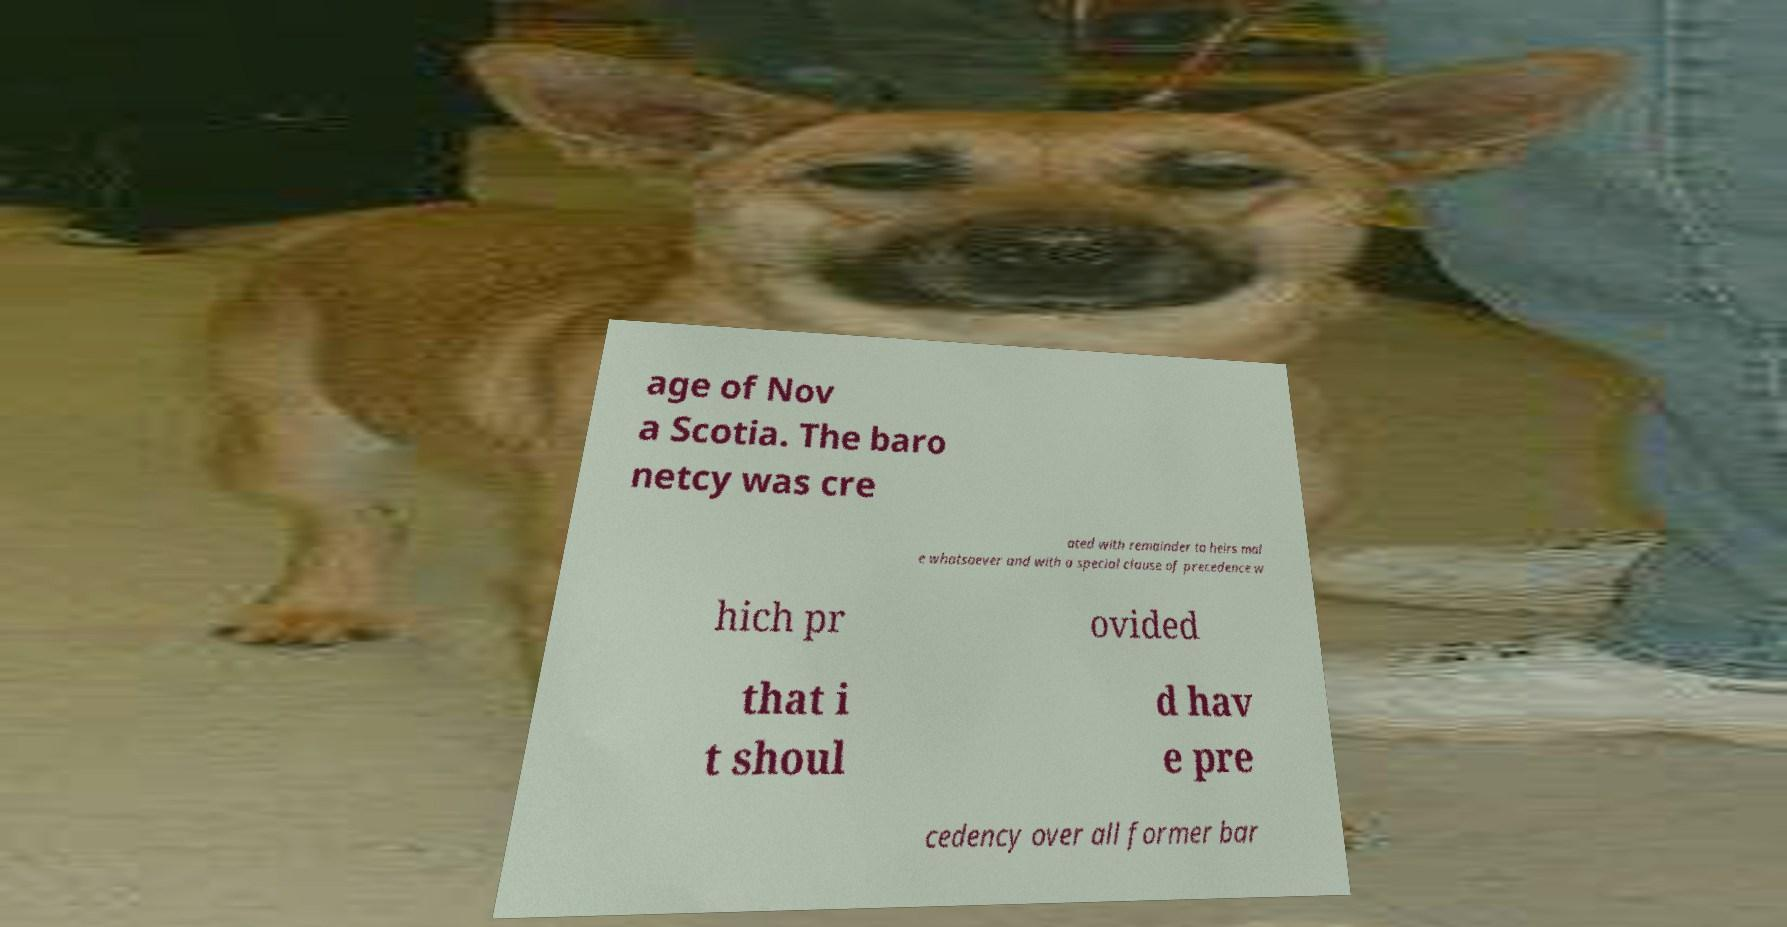Please identify and transcribe the text found in this image. age of Nov a Scotia. The baro netcy was cre ated with remainder to heirs mal e whatsoever and with a special clause of precedence w hich pr ovided that i t shoul d hav e pre cedency over all former bar 